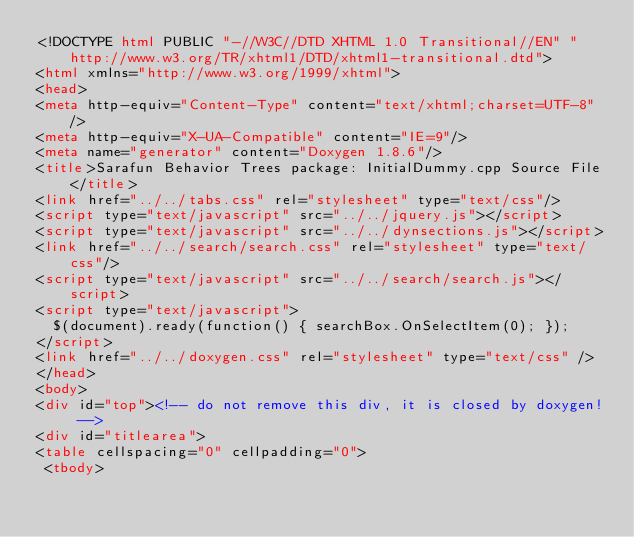<code> <loc_0><loc_0><loc_500><loc_500><_HTML_><!DOCTYPE html PUBLIC "-//W3C//DTD XHTML 1.0 Transitional//EN" "http://www.w3.org/TR/xhtml1/DTD/xhtml1-transitional.dtd">
<html xmlns="http://www.w3.org/1999/xhtml">
<head>
<meta http-equiv="Content-Type" content="text/xhtml;charset=UTF-8"/>
<meta http-equiv="X-UA-Compatible" content="IE=9"/>
<meta name="generator" content="Doxygen 1.8.6"/>
<title>Sarafun Behavior Trees package: InitialDummy.cpp Source File</title>
<link href="../../tabs.css" rel="stylesheet" type="text/css"/>
<script type="text/javascript" src="../../jquery.js"></script>
<script type="text/javascript" src="../../dynsections.js"></script>
<link href="../../search/search.css" rel="stylesheet" type="text/css"/>
<script type="text/javascript" src="../../search/search.js"></script>
<script type="text/javascript">
  $(document).ready(function() { searchBox.OnSelectItem(0); });
</script>
<link href="../../doxygen.css" rel="stylesheet" type="text/css" />
</head>
<body>
<div id="top"><!-- do not remove this div, it is closed by doxygen! -->
<div id="titlearea">
<table cellspacing="0" cellpadding="0">
 <tbody></code> 